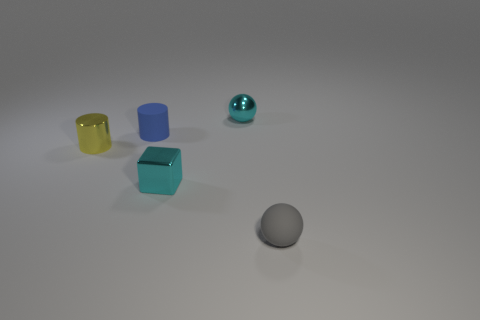Add 3 tiny yellow metallic balls. How many objects exist? 8 Subtract all cylinders. How many objects are left? 3 Subtract all gray objects. Subtract all shiny blocks. How many objects are left? 3 Add 1 blue rubber things. How many blue rubber things are left? 2 Add 1 small rubber spheres. How many small rubber spheres exist? 2 Subtract 0 yellow balls. How many objects are left? 5 